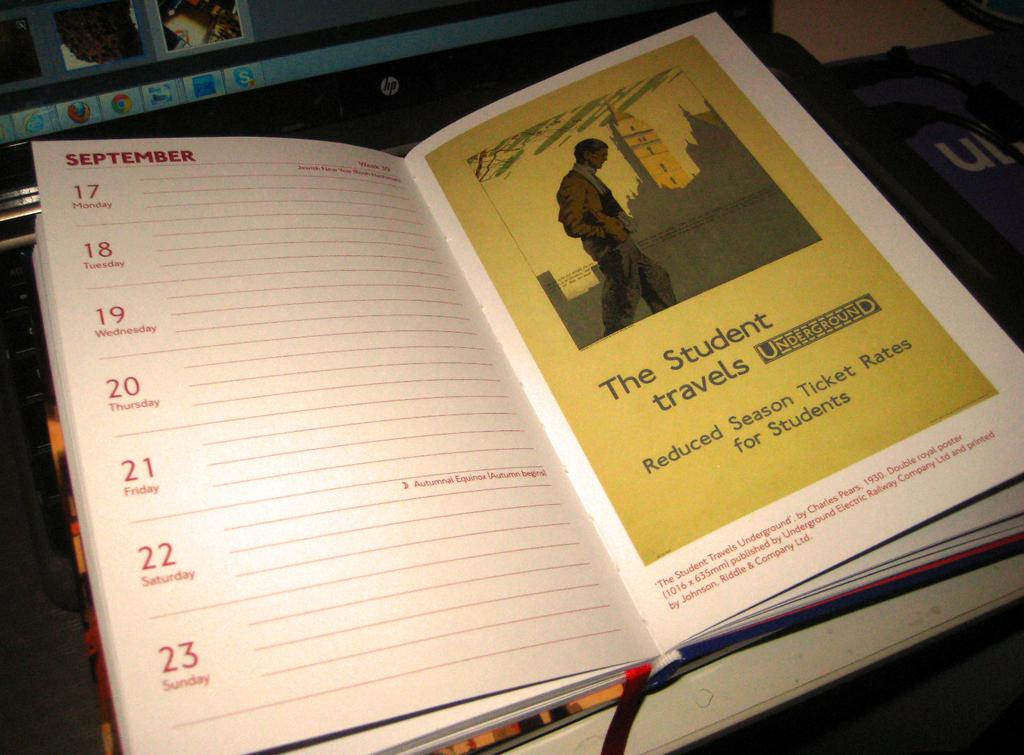<image>
Create a compact narrative representing the image presented. A open calendar book that is on the month of September. 